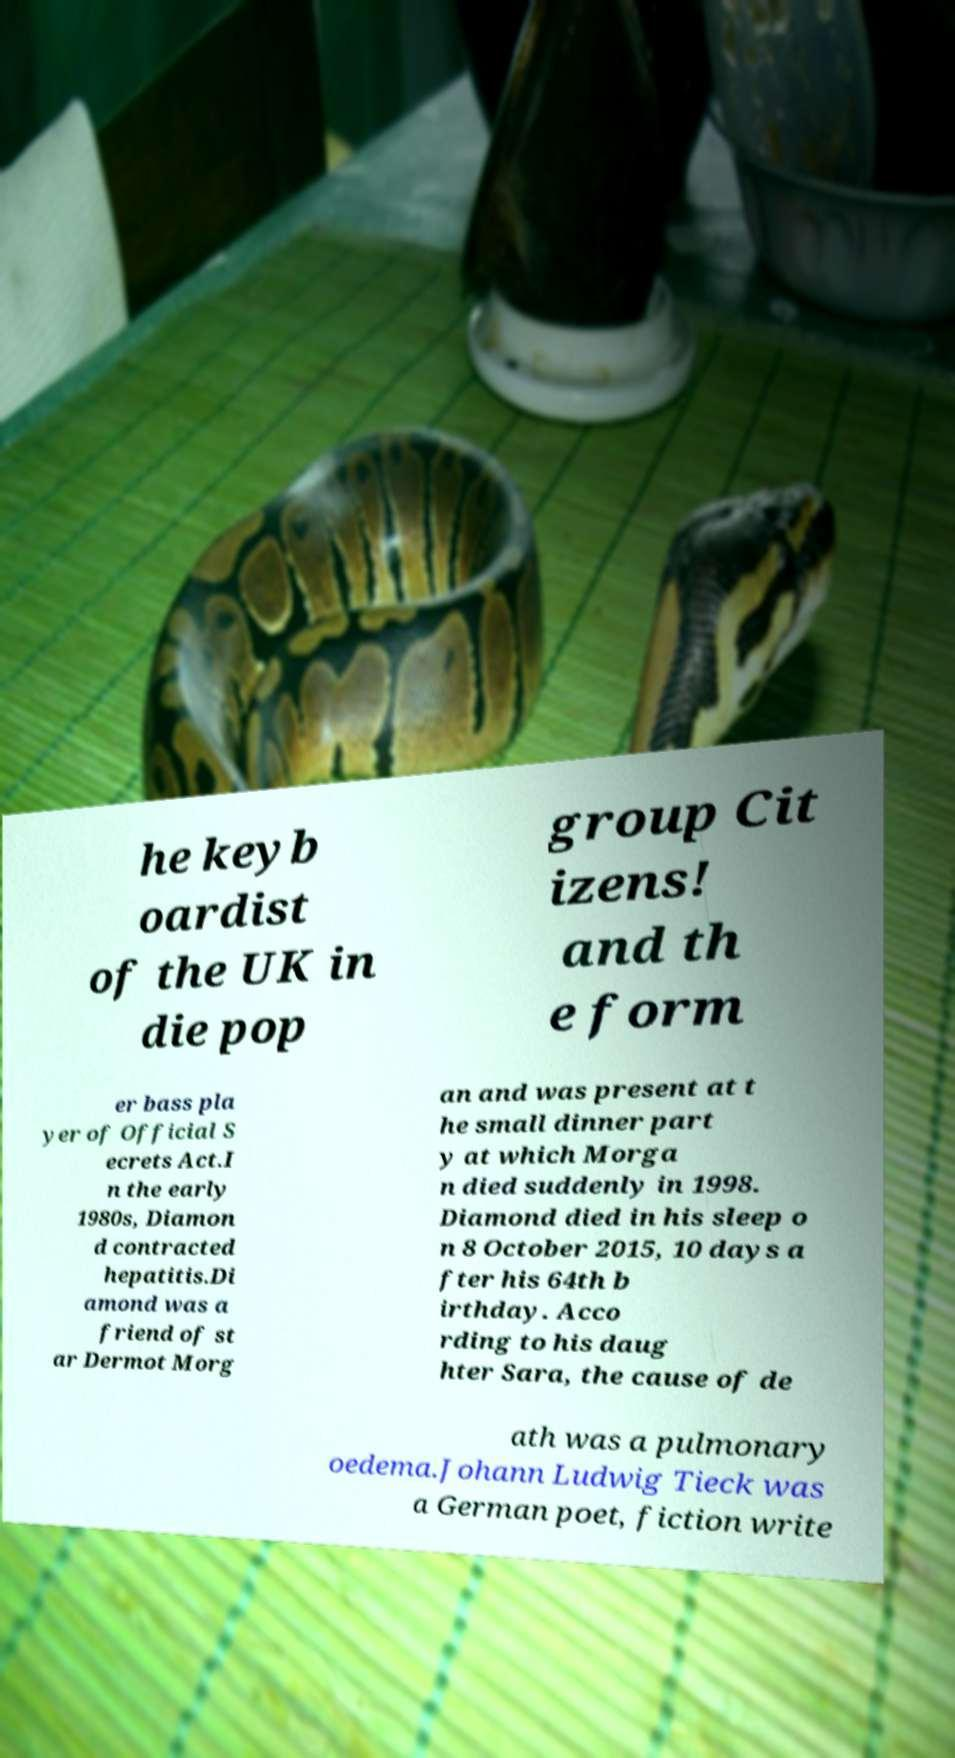What messages or text are displayed in this image? I need them in a readable, typed format. he keyb oardist of the UK in die pop group Cit izens! and th e form er bass pla yer of Official S ecrets Act.I n the early 1980s, Diamon d contracted hepatitis.Di amond was a friend of st ar Dermot Morg an and was present at t he small dinner part y at which Morga n died suddenly in 1998. Diamond died in his sleep o n 8 October 2015, 10 days a fter his 64th b irthday. Acco rding to his daug hter Sara, the cause of de ath was a pulmonary oedema.Johann Ludwig Tieck was a German poet, fiction write 